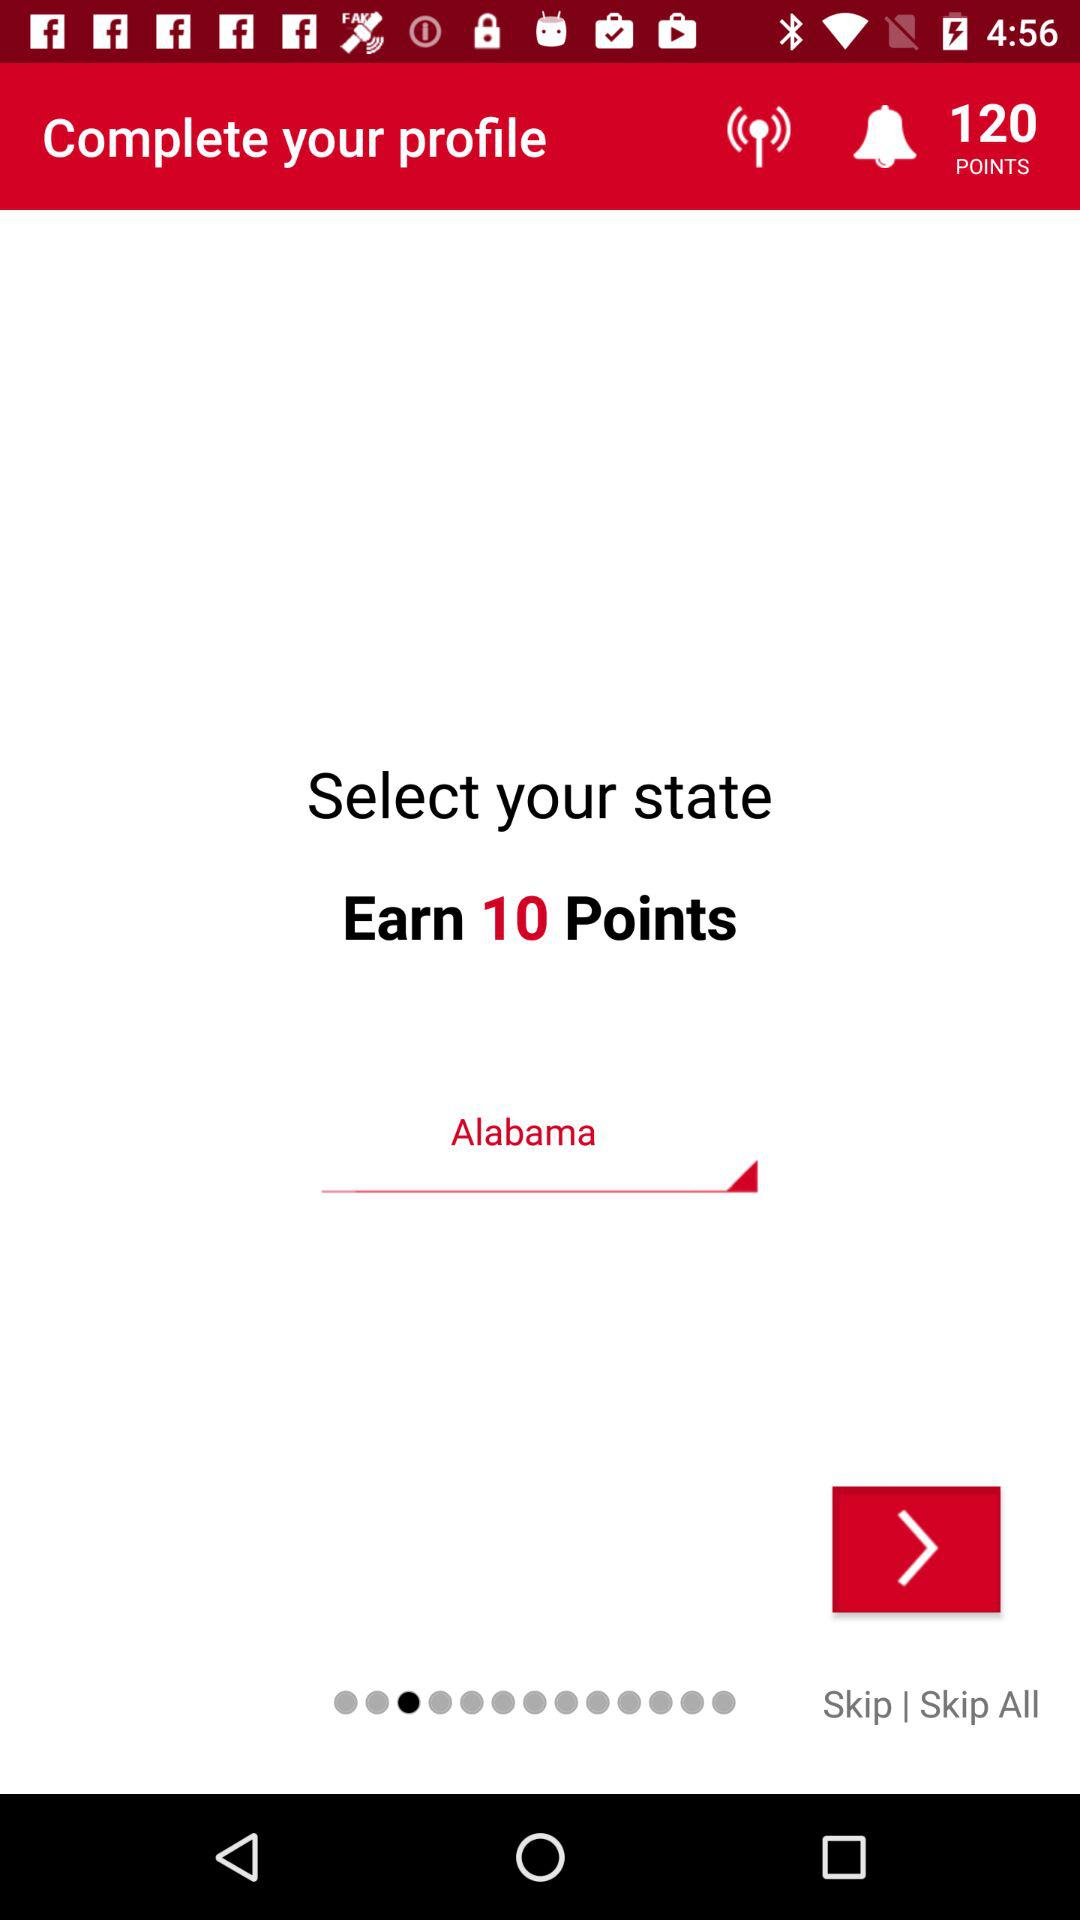How many points do I have to earn to complete my profile?
Answer the question using a single word or phrase. 10 